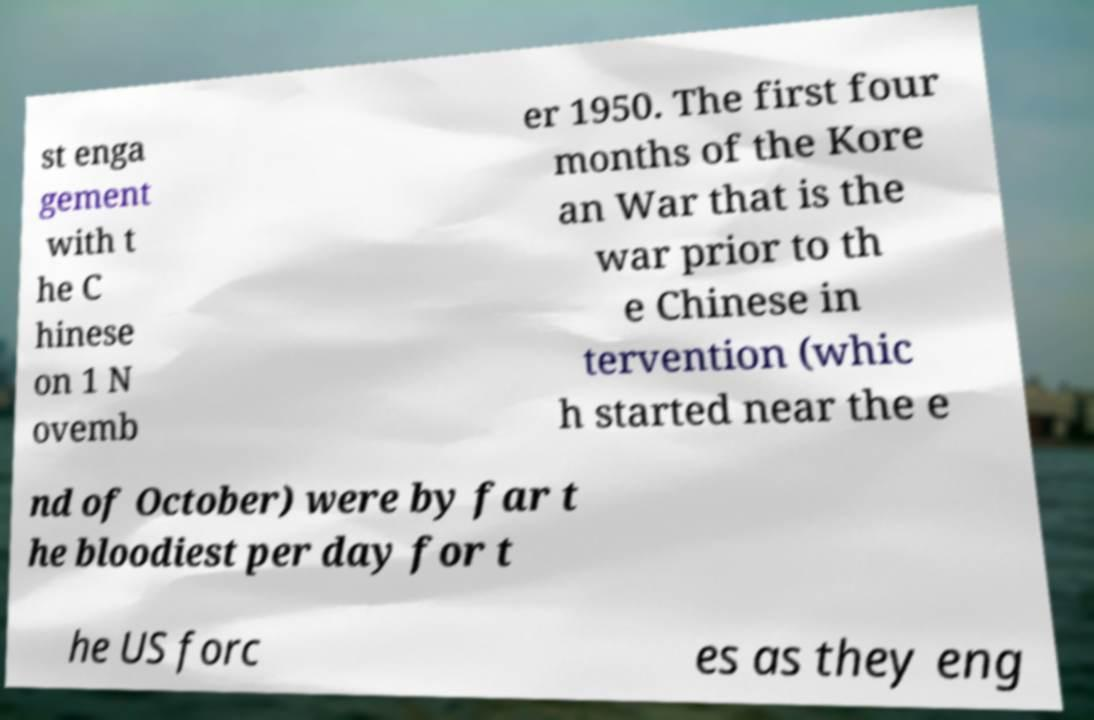Could you extract and type out the text from this image? st enga gement with t he C hinese on 1 N ovemb er 1950. The first four months of the Kore an War that is the war prior to th e Chinese in tervention (whic h started near the e nd of October) were by far t he bloodiest per day for t he US forc es as they eng 